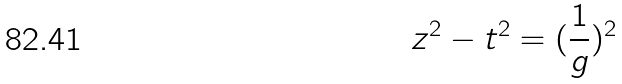Convert formula to latex. <formula><loc_0><loc_0><loc_500><loc_500>z ^ { 2 } - t ^ { 2 } = ( \frac { 1 } { g } ) ^ { 2 }</formula> 